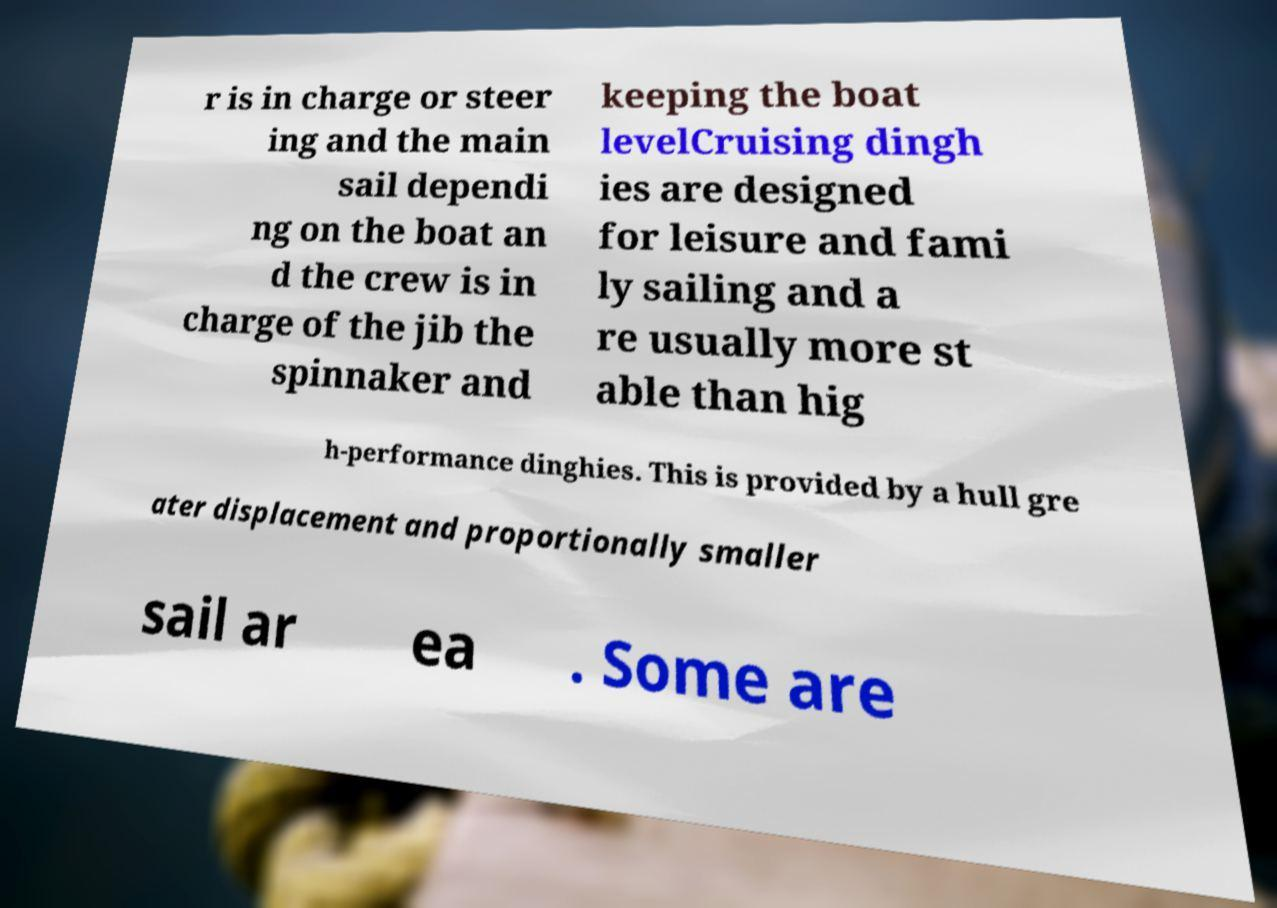Could you assist in decoding the text presented in this image and type it out clearly? r is in charge or steer ing and the main sail dependi ng on the boat an d the crew is in charge of the jib the spinnaker and keeping the boat levelCruising dingh ies are designed for leisure and fami ly sailing and a re usually more st able than hig h-performance dinghies. This is provided by a hull gre ater displacement and proportionally smaller sail ar ea . Some are 